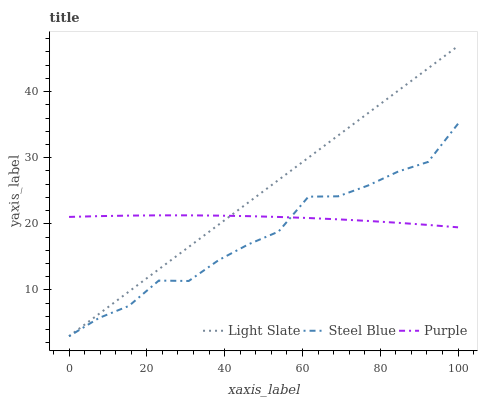Does Steel Blue have the minimum area under the curve?
Answer yes or no. Yes. Does Light Slate have the maximum area under the curve?
Answer yes or no. Yes. Does Purple have the minimum area under the curve?
Answer yes or no. No. Does Purple have the maximum area under the curve?
Answer yes or no. No. Is Light Slate the smoothest?
Answer yes or no. Yes. Is Steel Blue the roughest?
Answer yes or no. Yes. Is Purple the smoothest?
Answer yes or no. No. Is Purple the roughest?
Answer yes or no. No. Does Light Slate have the lowest value?
Answer yes or no. Yes. Does Purple have the lowest value?
Answer yes or no. No. Does Light Slate have the highest value?
Answer yes or no. Yes. Does Steel Blue have the highest value?
Answer yes or no. No. Does Steel Blue intersect Purple?
Answer yes or no. Yes. Is Steel Blue less than Purple?
Answer yes or no. No. Is Steel Blue greater than Purple?
Answer yes or no. No. 